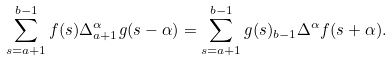Convert formula to latex. <formula><loc_0><loc_0><loc_500><loc_500>\sum _ { s = a + 1 } ^ { b - 1 } f ( s ) \Delta _ { a + 1 } ^ { \alpha } g ( s - \alpha ) = \sum _ { s = a + 1 } ^ { b - 1 } g ( s ) _ { b - 1 } \Delta ^ { \alpha } f ( s + \alpha ) .</formula> 